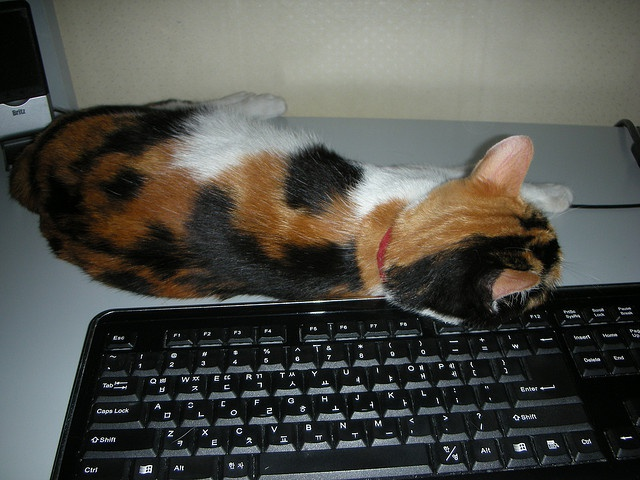Describe the objects in this image and their specific colors. I can see keyboard in black, gray, darkgray, and navy tones and cat in black, darkgray, and maroon tones in this image. 